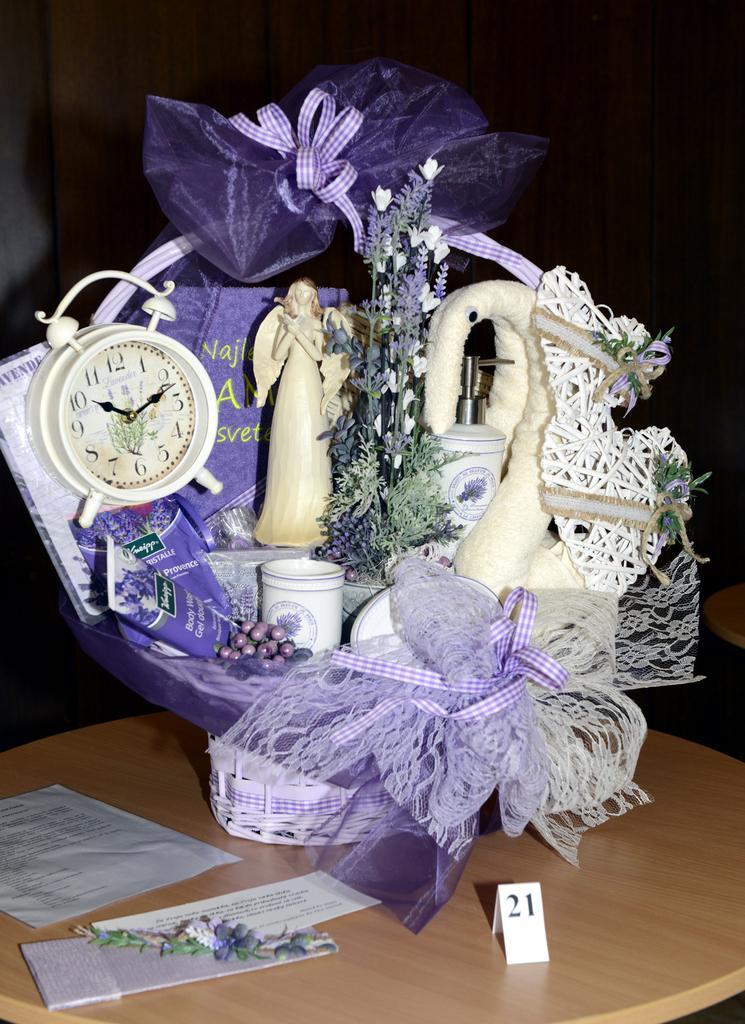How would you summarize this image in a sentence or two? In this image there is a wooden surface. On that there are papers and a basket. On the basket there are clothes, papers, ribbons, flowers, statue and a clock. In the background it is dark. 